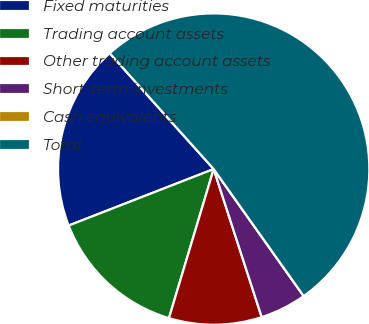Convert chart. <chart><loc_0><loc_0><loc_500><loc_500><pie_chart><fcel>Fixed maturities<fcel>Trading account assets<fcel>Other trading account assets<fcel>Short-term investments<fcel>Cash equivalents<fcel>Total<nl><fcel>19.27%<fcel>14.45%<fcel>9.63%<fcel>4.82%<fcel>0.0%<fcel>51.83%<nl></chart> 